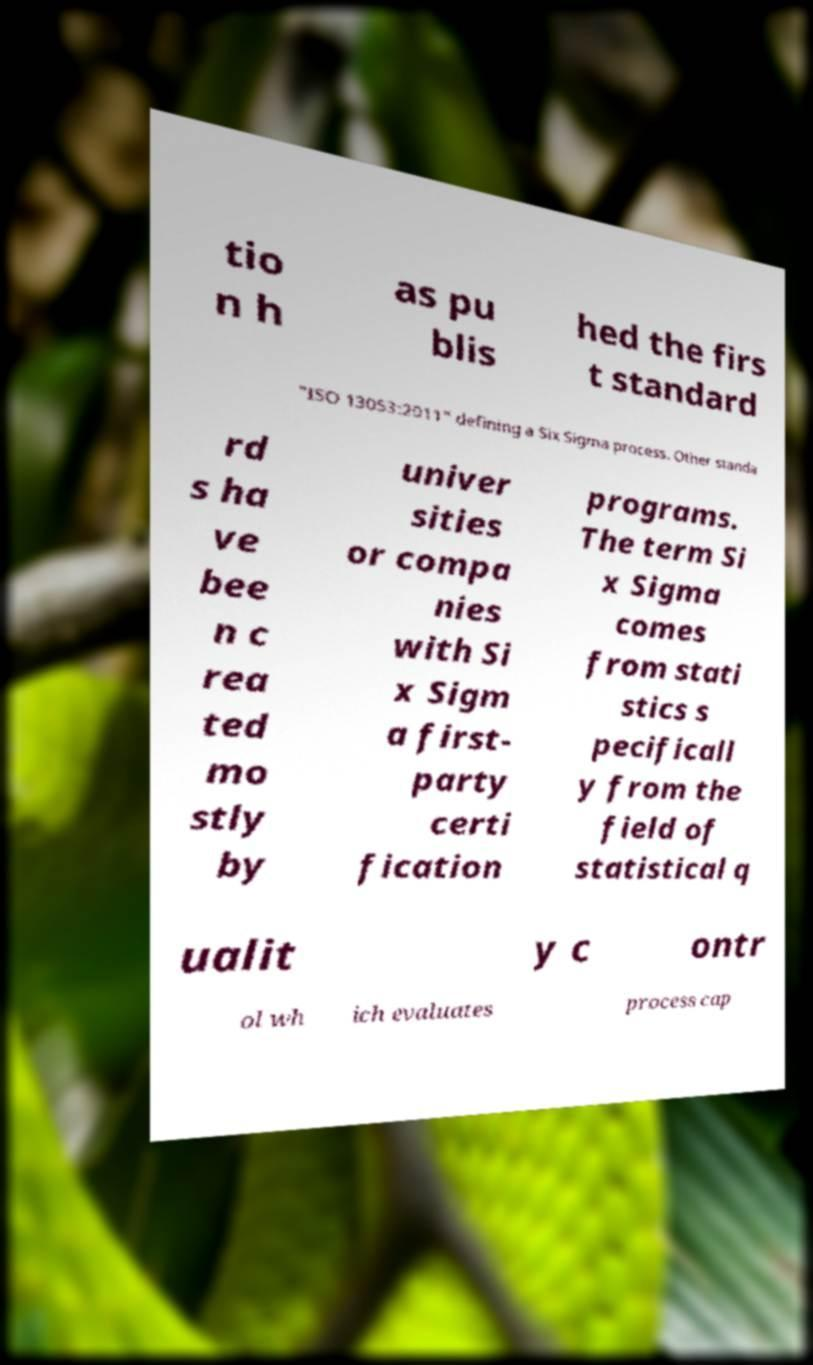Please read and relay the text visible in this image. What does it say? tio n h as pu blis hed the firs t standard "ISO 13053:2011" defining a Six Sigma process. Other standa rd s ha ve bee n c rea ted mo stly by univer sities or compa nies with Si x Sigm a first- party certi fication programs. The term Si x Sigma comes from stati stics s pecificall y from the field of statistical q ualit y c ontr ol wh ich evaluates process cap 